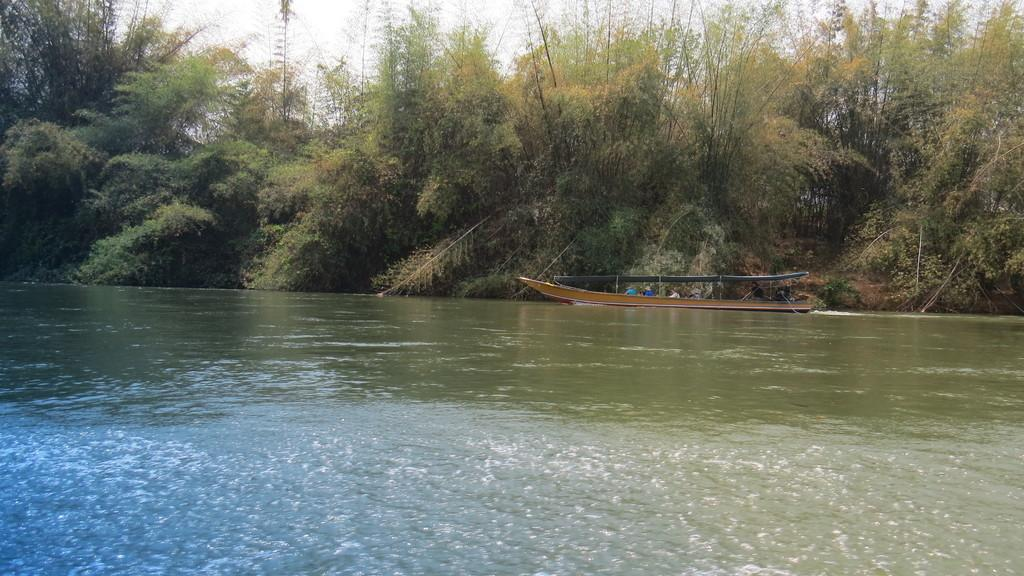What is the main element in the image? There is water in the image. What is on the water in the image? There is a boat standing on the water. Who is in the boat? There are people sitting in the boat. What can be seen in the background of the image? There are trees visible in the background of the image. What type of elbow can be seen in the image? There is no elbow present in the image. Can you tell me how many ears are visible in the image? There are no ears visible in the image. 